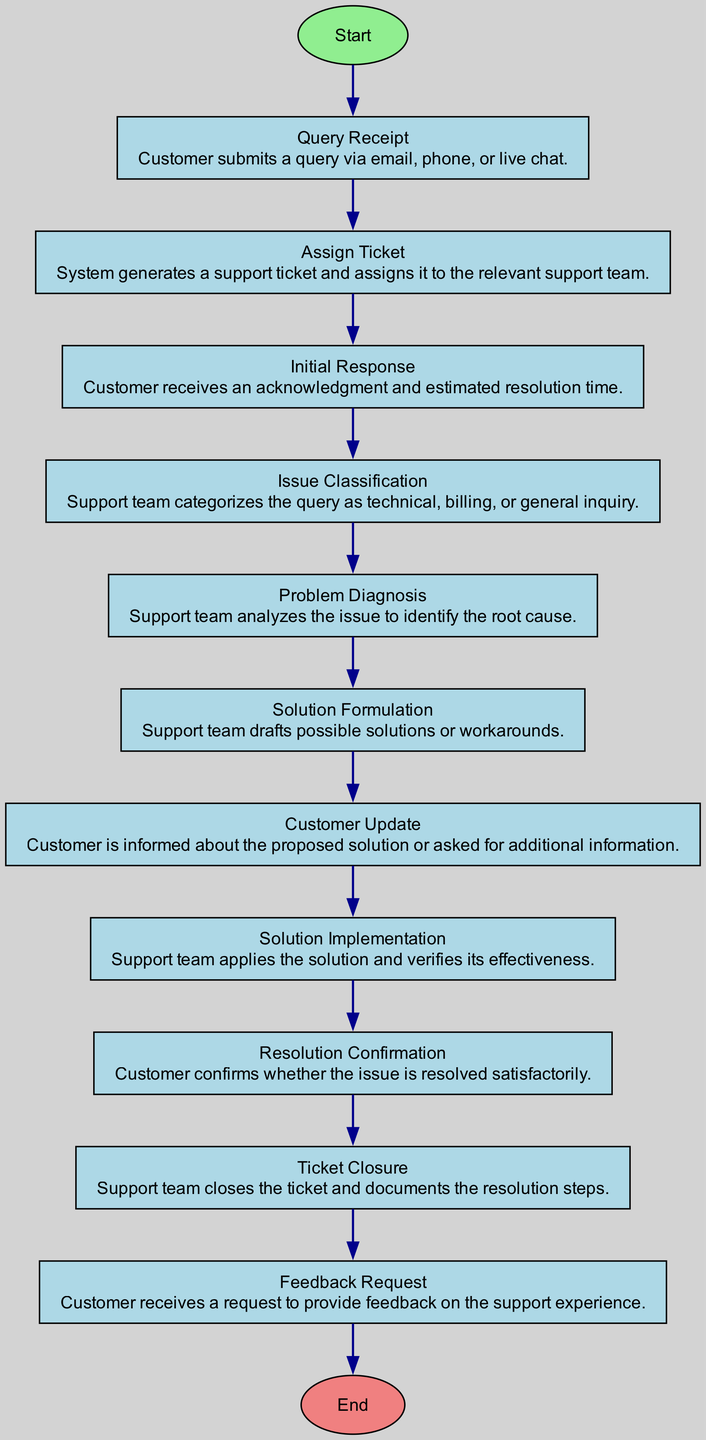What is the first step in the customer support process? The first step is indicated by the "start" node, which flows into the "Query Receipt." This means that the process begins when a customer submits a query via email, phone, or live chat.
Answer: Query Receipt How many total nodes are there in the diagram? The diagram has a total of 11 nodes, including the start and end nodes. It consists of 10 elements from "Query Receipt" to "Ticket Closure," and the start and end nodes make it 11.
Answer: 11 What is the stage that follows "Initial Response"? The stage that follows "Initial Response" is "Issue Classification." This is determined by looking at the flow from the "Initial Response" node to the next node in the direction of the arrows.
Answer: Issue Classification What type of query does the support team analyze during the "Problem Diagnosis" stage? During the "Problem Diagnosis" stage, the support team analyzes the query to identify its root cause, which involves understanding the issue and its intricacies.
Answer: The issue What action is taken after the customer is updated about the proposed solution? After the customer is updated about the proposed solution, the next action is "Solution Implementation." This can be seen from the flow of the diagram where the "Customer Update" node connects to the subsequent "Solution Implementation" node.
Answer: Solution Implementation What happens to the support ticket after the resolution confirmation? After the resolution confirmation is received from the customer, the support team proceeds to "Ticket Closure." This step involves finalizing the support process by documenting the resolution and closing the ticket.
Answer: Ticket Closure What is received by the customer after the ticket is closed? After the ticket is closed, the customer receives a "Feedback Request," indicating that the process now invites feedback on their support experience. This follows logically from the "Ticket Closure" node.
Answer: Feedback Request Which type of issue might not require a technical solution in this process? A "general inquiry" is a type of issue that typically does not require a technical solution. The support team classifies queries and determines the necessary approach based on the type of inquiry.
Answer: General inquiry How many edges are in the diagram? The diagram consists of 10 edges which correspond to the transitions between the 11 nodes. Each transition reflects the flow from one step to the next.
Answer: 10 